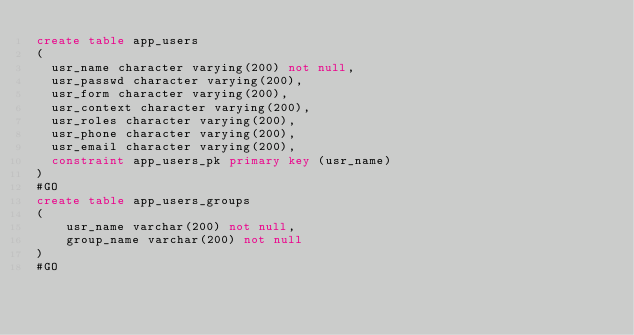Convert code to text. <code><loc_0><loc_0><loc_500><loc_500><_SQL_>create table app_users
(
  usr_name character varying(200) not null,
  usr_passwd character varying(200),
  usr_form character varying(200),
  usr_context character varying(200),
  usr_roles character varying(200),
  usr_phone character varying(200),
  usr_email character varying(200),
  constraint app_users_pk primary key (usr_name)
)
#GO
create table app_users_groups
(
    usr_name varchar(200) not null,
    group_name varchar(200) not null
)
#GO</code> 